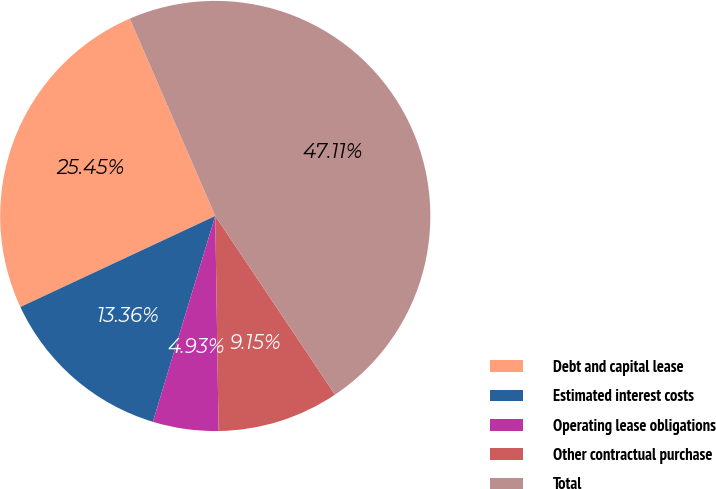Convert chart. <chart><loc_0><loc_0><loc_500><loc_500><pie_chart><fcel>Debt and capital lease<fcel>Estimated interest costs<fcel>Operating lease obligations<fcel>Other contractual purchase<fcel>Total<nl><fcel>25.45%<fcel>13.36%<fcel>4.93%<fcel>9.15%<fcel>47.11%<nl></chart> 